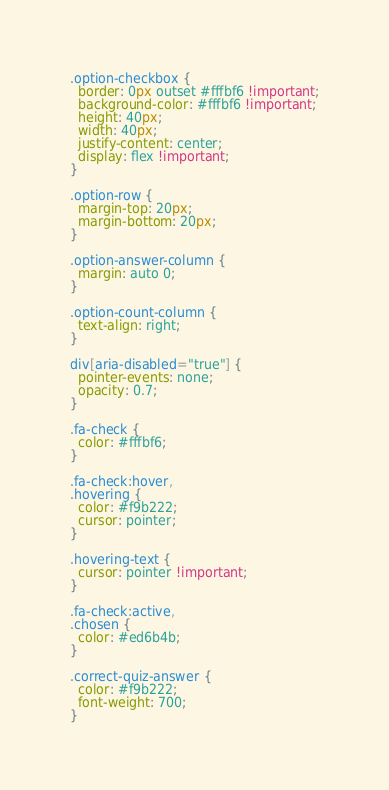Convert code to text. <code><loc_0><loc_0><loc_500><loc_500><_CSS_>.option-checkbox {
  border: 0px outset #fffbf6 !important;
  background-color: #fffbf6 !important;
  height: 40px;
  width: 40px;
  justify-content: center;
  display: flex !important;
}

.option-row {
  margin-top: 20px;
  margin-bottom: 20px;
}

.option-answer-column {
  margin: auto 0;
}

.option-count-column {
  text-align: right;
}

div[aria-disabled="true"] {
  pointer-events: none;
  opacity: 0.7;
}

.fa-check {
  color: #fffbf6;
}

.fa-check:hover,
.hovering {
  color: #f9b222;
  cursor: pointer;
}

.hovering-text {
  cursor: pointer !important;
}

.fa-check:active,
.chosen {
  color: #ed6b4b;
}

.correct-quiz-answer {
  color: #f9b222;
  font-weight: 700;
}
</code> 